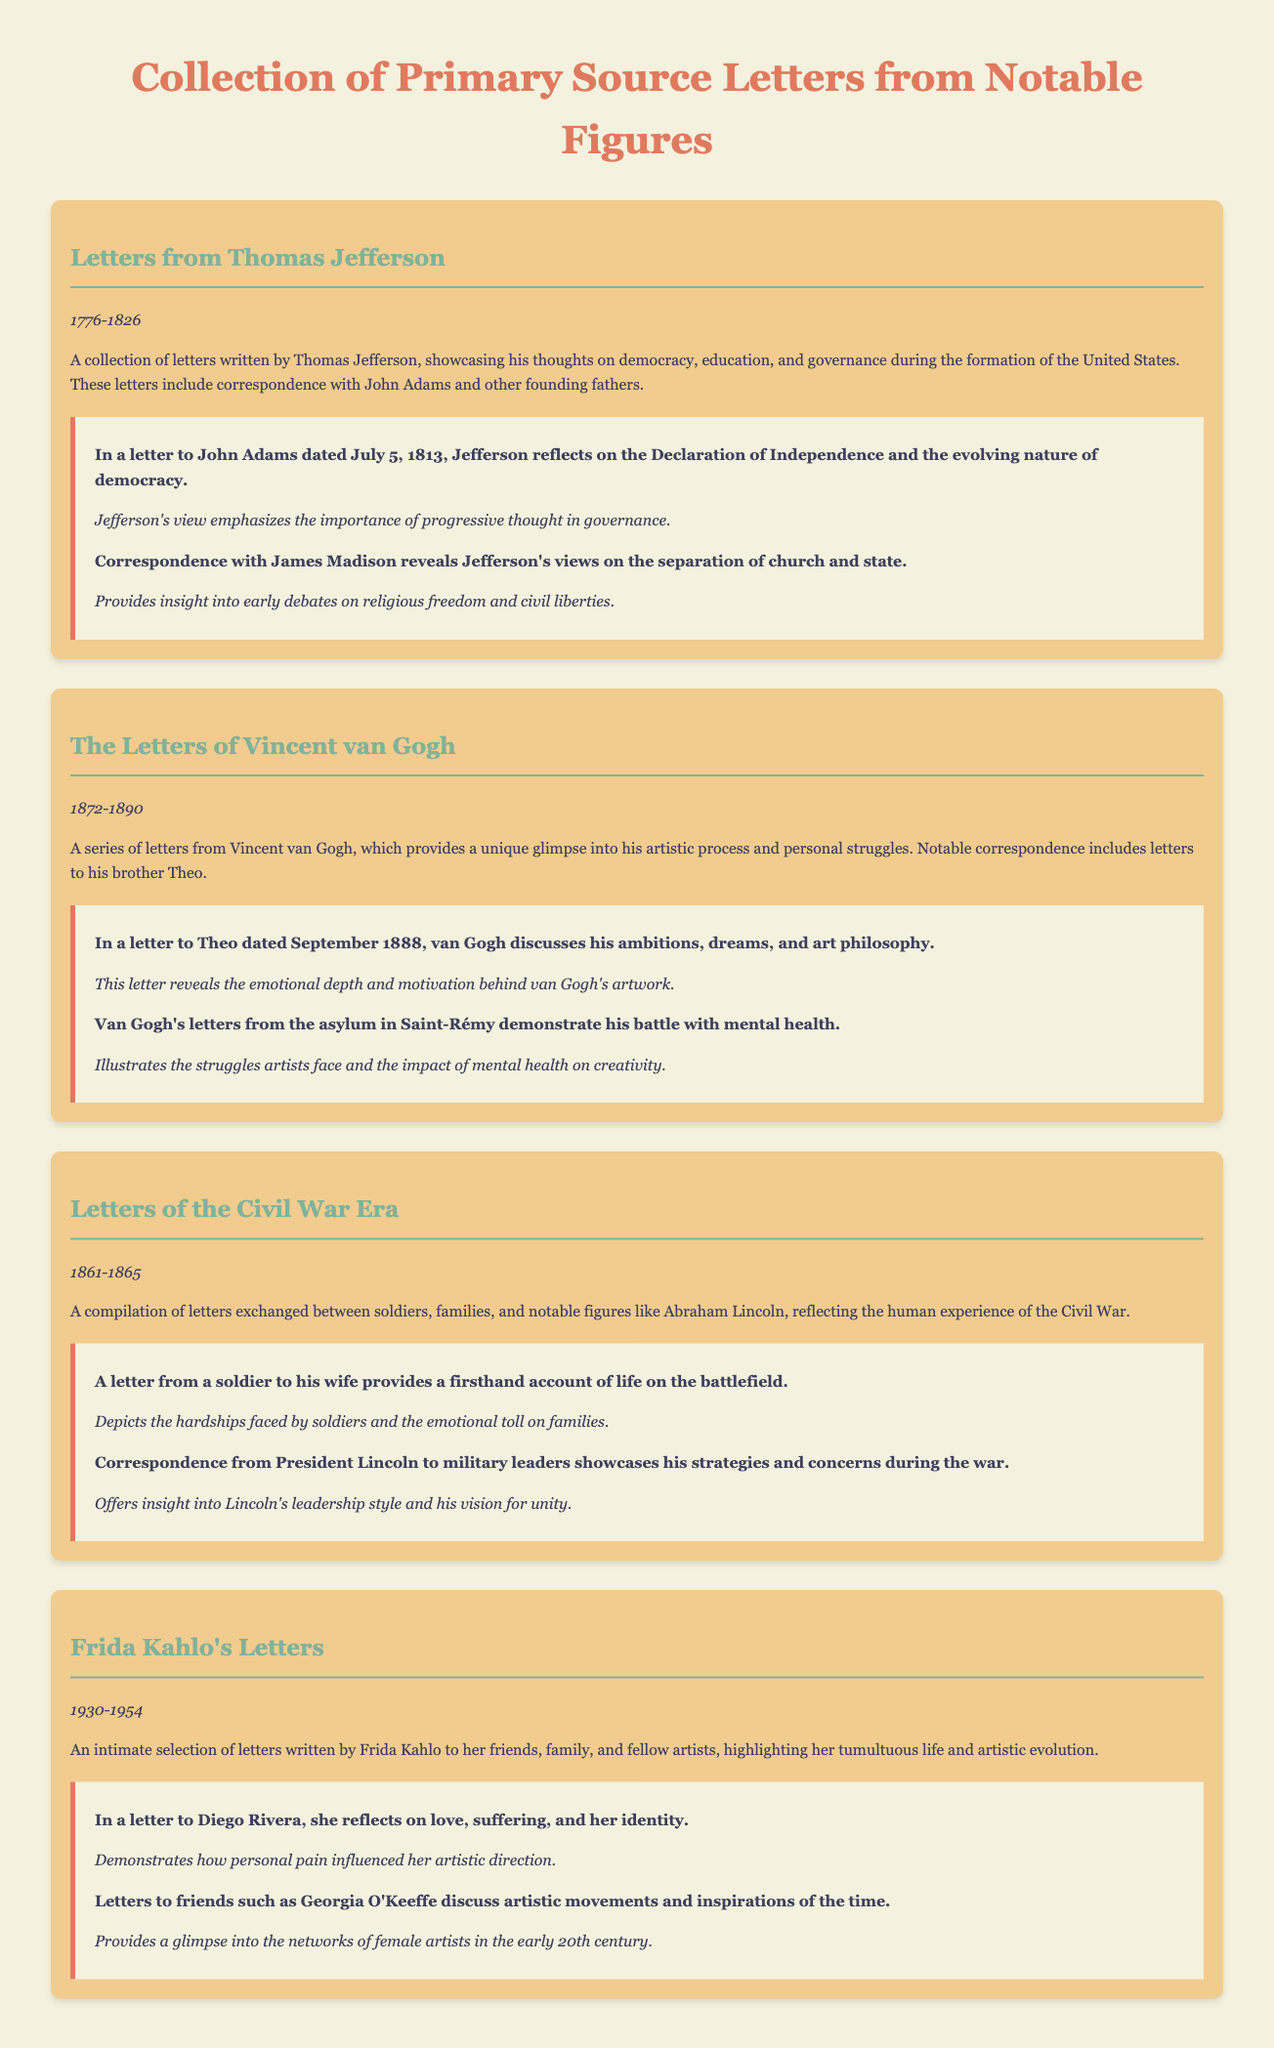what time period do the letters from Thomas Jefferson cover? The letters from Thomas Jefferson span from 1776 to 1826, as indicated in the document.
Answer: 1776-1826 who did Vincent van Gogh frequently write to? The document mentions that Vincent van Gogh notably corresponded with his brother Theo.
Answer: Theo what is the main theme of Frida Kahlo's letters? The letters highlight her tumultuous life and artistic evolution, which is explained in the description.
Answer: tumultuous life and artistic evolution how many letters are included in the Civil War Era collection? The document does not specify an exact number of letters, only that it is a compilation reflecting the human experience of the Civil War.
Answer: compilation what is the insight provided in Jefferson's letter to John Adams? The document states that Jefferson emphasizes the importance of progressive thought in governance through this correspondence.
Answer: importance of progressive thought in governance what time span does the collection of Vincent van Gogh's letters cover? The letters from Vincent van Gogh cover the time period from 1872 to 1890, as mentioned in the document.
Answer: 1872-1890 what significant issue does Jefferson discuss in his letters with James Madison? The letters reveal Jefferson's views on the separation of church and state, as highlighted in the annotations.
Answer: separation of church and state which letter reflects Frida Kahlo's thoughts on identity? The letter to Diego Rivera discusses love, suffering, and her identity, as noted in the document.
Answer: letter to Diego Rivera 